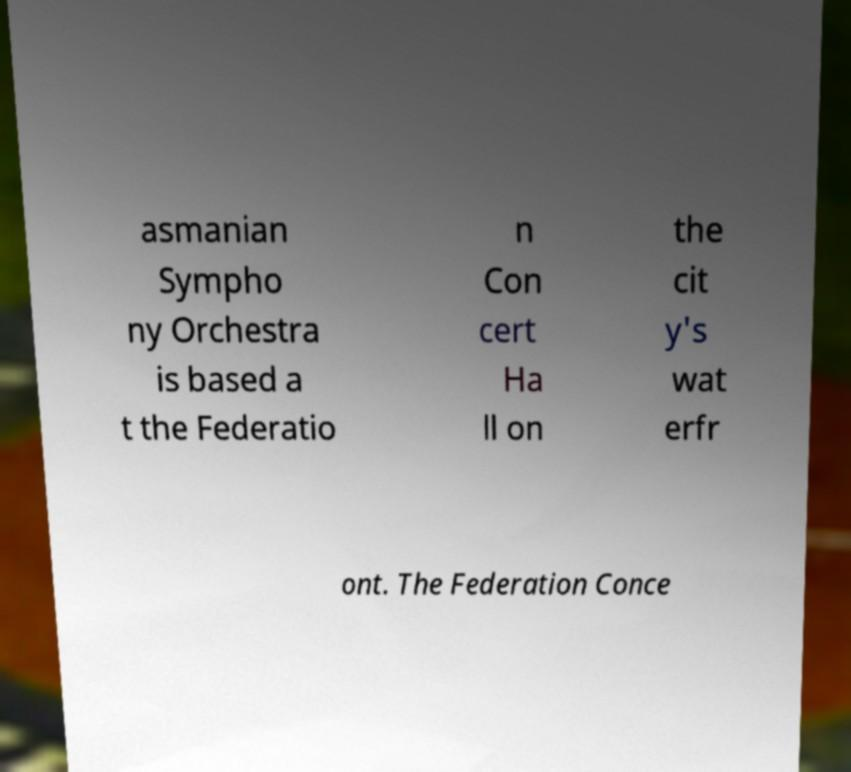Can you accurately transcribe the text from the provided image for me? asmanian Sympho ny Orchestra is based a t the Federatio n Con cert Ha ll on the cit y's wat erfr ont. The Federation Conce 